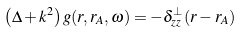Convert formula to latex. <formula><loc_0><loc_0><loc_500><loc_500>\left ( \Delta + k ^ { 2 } \right ) g ( r , r _ { A } , \omega ) = - \delta _ { z z } ^ { \perp } ( r - r _ { A } )</formula> 